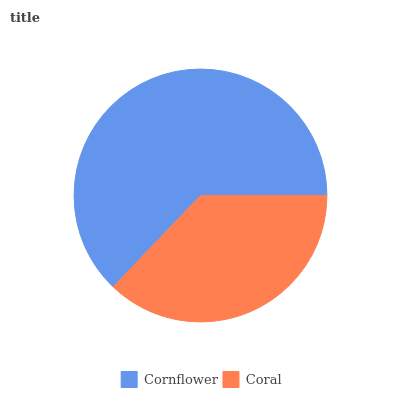Is Coral the minimum?
Answer yes or no. Yes. Is Cornflower the maximum?
Answer yes or no. Yes. Is Coral the maximum?
Answer yes or no. No. Is Cornflower greater than Coral?
Answer yes or no. Yes. Is Coral less than Cornflower?
Answer yes or no. Yes. Is Coral greater than Cornflower?
Answer yes or no. No. Is Cornflower less than Coral?
Answer yes or no. No. Is Cornflower the high median?
Answer yes or no. Yes. Is Coral the low median?
Answer yes or no. Yes. Is Coral the high median?
Answer yes or no. No. Is Cornflower the low median?
Answer yes or no. No. 